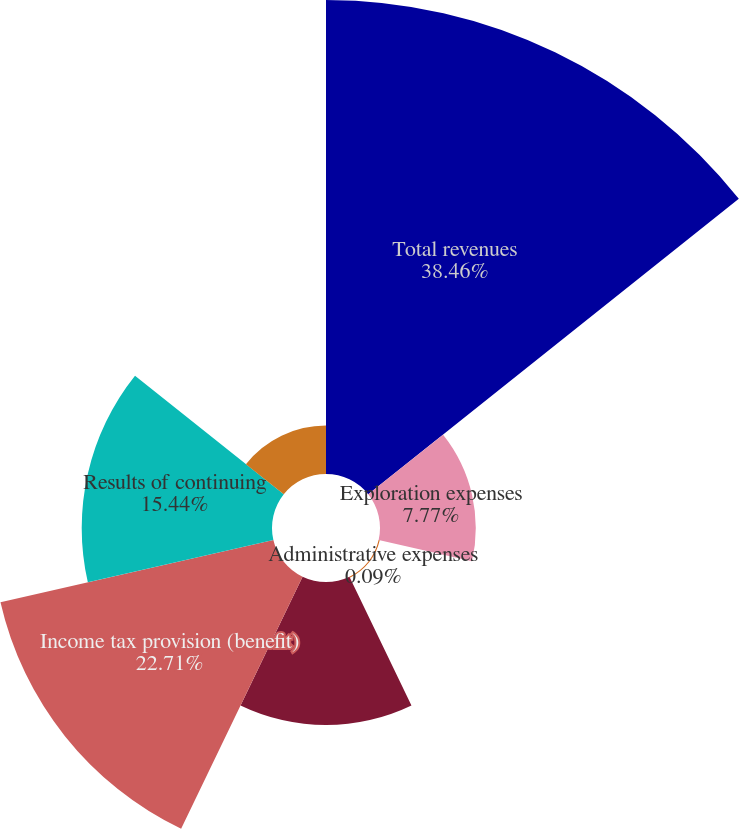Convert chart to OTSL. <chart><loc_0><loc_0><loc_500><loc_500><pie_chart><fcel>Total revenues<fcel>Exploration expenses<fcel>Administrative expenses<fcel>Total expenses<fcel>Income tax provision (benefit)<fcel>Results of continuing<fcel>Production costs<nl><fcel>38.46%<fcel>7.77%<fcel>0.09%<fcel>11.6%<fcel>22.71%<fcel>15.44%<fcel>3.93%<nl></chart> 